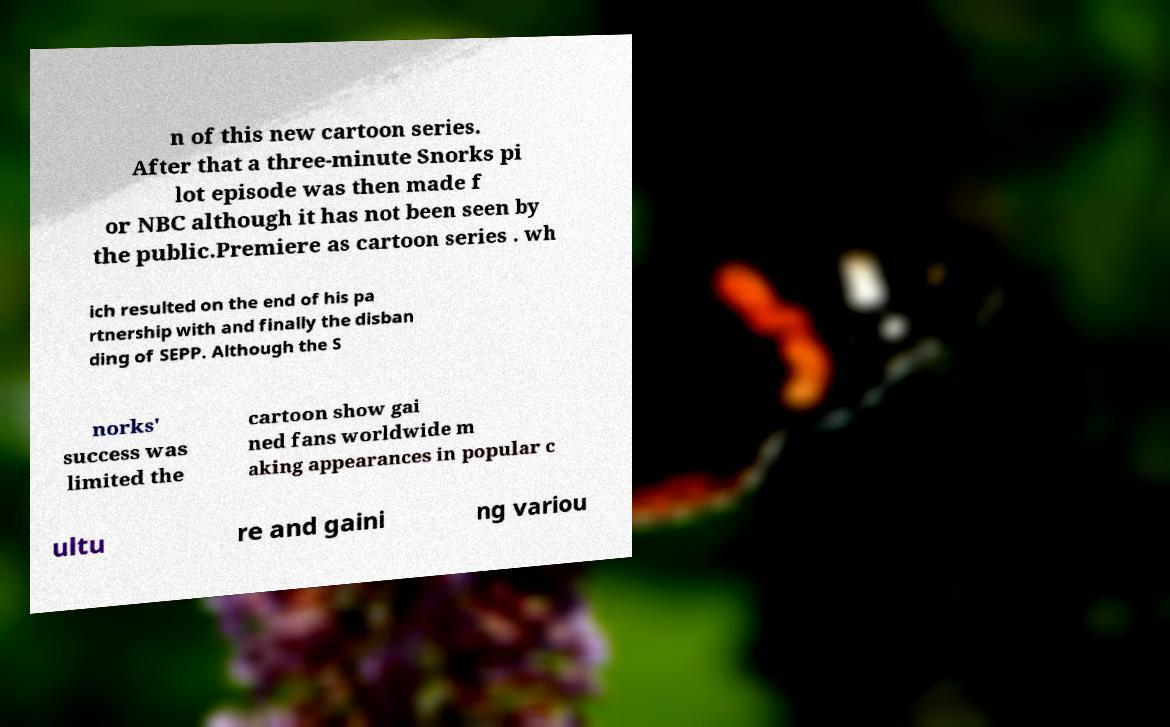I need the written content from this picture converted into text. Can you do that? n of this new cartoon series. After that a three-minute Snorks pi lot episode was then made f or NBC although it has not been seen by the public.Premiere as cartoon series . wh ich resulted on the end of his pa rtnership with and finally the disban ding of SEPP. Although the S norks' success was limited the cartoon show gai ned fans worldwide m aking appearances in popular c ultu re and gaini ng variou 